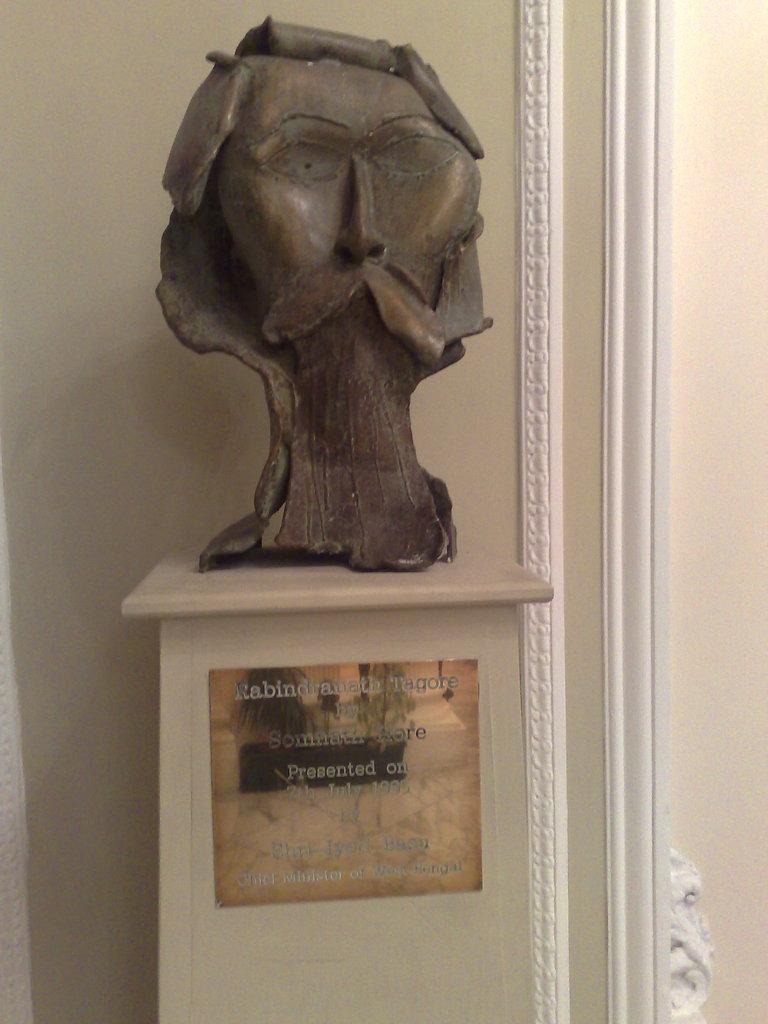How would you summarize this image in a sentence or two? In the center of the image we can see statue. In the background there is wall. 